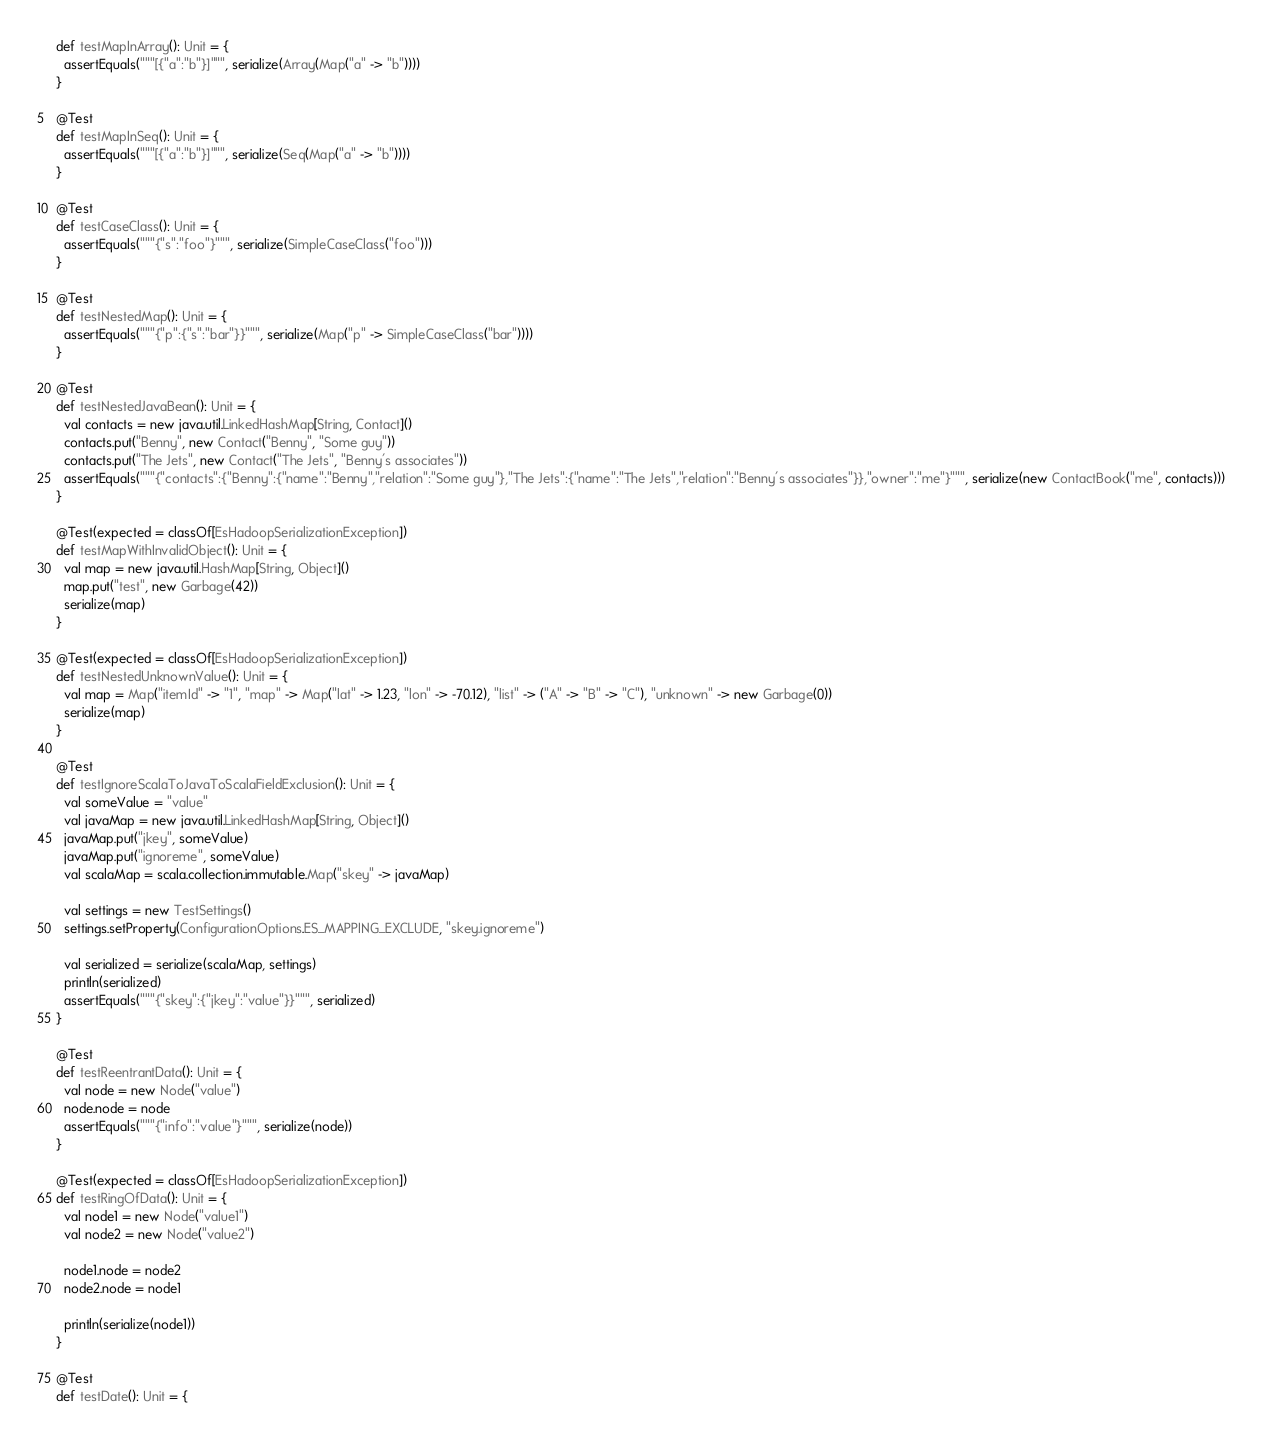Convert code to text. <code><loc_0><loc_0><loc_500><loc_500><_Scala_>  def testMapInArray(): Unit = {
    assertEquals("""[{"a":"b"}]""", serialize(Array(Map("a" -> "b"))))
  }

  @Test
  def testMapInSeq(): Unit = {
    assertEquals("""[{"a":"b"}]""", serialize(Seq(Map("a" -> "b"))))
  }

  @Test
  def testCaseClass(): Unit = {
    assertEquals("""{"s":"foo"}""", serialize(SimpleCaseClass("foo")))
  }

  @Test
  def testNestedMap(): Unit = {
    assertEquals("""{"p":{"s":"bar"}}""", serialize(Map("p" -> SimpleCaseClass("bar"))))
  }

  @Test
  def testNestedJavaBean(): Unit = {
    val contacts = new java.util.LinkedHashMap[String, Contact]()
    contacts.put("Benny", new Contact("Benny", "Some guy"))
    contacts.put("The Jets", new Contact("The Jets", "Benny's associates"))
    assertEquals("""{"contacts":{"Benny":{"name":"Benny","relation":"Some guy"},"The Jets":{"name":"The Jets","relation":"Benny's associates"}},"owner":"me"}""", serialize(new ContactBook("me", contacts)))
  }

  @Test(expected = classOf[EsHadoopSerializationException])
  def testMapWithInvalidObject(): Unit = {
    val map = new java.util.HashMap[String, Object]()
    map.put("test", new Garbage(42))
    serialize(map)
  }

  @Test(expected = classOf[EsHadoopSerializationException])
  def testNestedUnknownValue(): Unit = {
    val map = Map("itemId" -> "1", "map" -> Map("lat" -> 1.23, "lon" -> -70.12), "list" -> ("A" -> "B" -> "C"), "unknown" -> new Garbage(0))
    serialize(map)
  }

  @Test
  def testIgnoreScalaToJavaToScalaFieldExclusion(): Unit = {
    val someValue = "value"
    val javaMap = new java.util.LinkedHashMap[String, Object]()
    javaMap.put("jkey", someValue)
    javaMap.put("ignoreme", someValue)
    val scalaMap = scala.collection.immutable.Map("skey" -> javaMap)

    val settings = new TestSettings()
    settings.setProperty(ConfigurationOptions.ES_MAPPING_EXCLUDE, "skey.ignoreme")

    val serialized = serialize(scalaMap, settings)
    println(serialized)
    assertEquals("""{"skey":{"jkey":"value"}}""", serialized)
  }

  @Test
  def testReentrantData(): Unit = {
    val node = new Node("value")
    node.node = node
    assertEquals("""{"info":"value"}""", serialize(node))
  }

  @Test(expected = classOf[EsHadoopSerializationException])
  def testRingOfData(): Unit = {
    val node1 = new Node("value1")
    val node2 = new Node("value2")

    node1.node = node2
    node2.node = node1

    println(serialize(node1))
  }

  @Test
  def testDate(): Unit = {</code> 